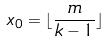<formula> <loc_0><loc_0><loc_500><loc_500>x _ { 0 } = \lfloor \frac { m } { k - 1 } \rfloor</formula> 